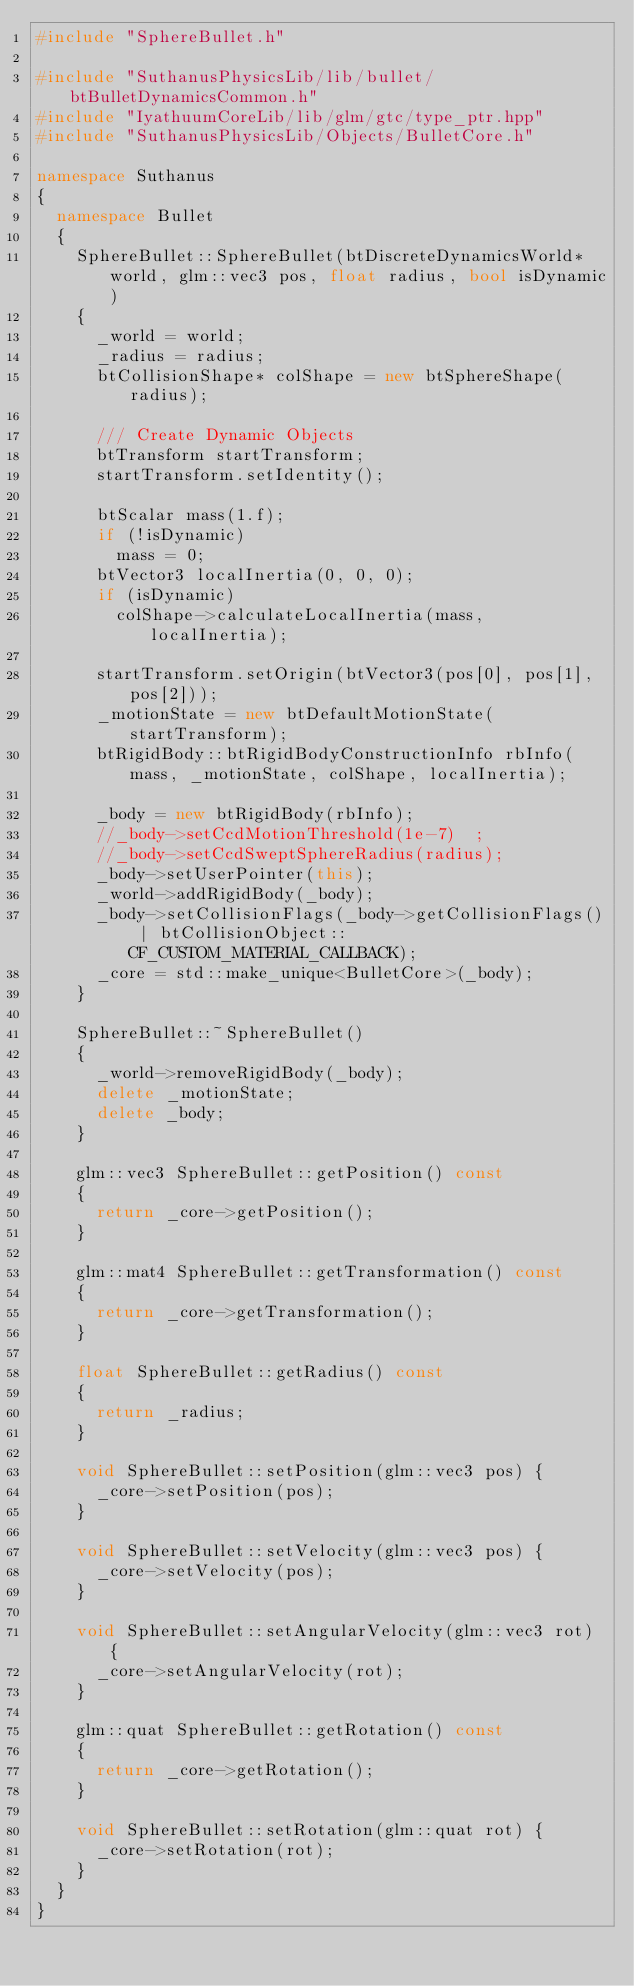<code> <loc_0><loc_0><loc_500><loc_500><_C++_>#include "SphereBullet.h"

#include "SuthanusPhysicsLib/lib/bullet/btBulletDynamicsCommon.h"
#include "IyathuumCoreLib/lib/glm/gtc/type_ptr.hpp"
#include "SuthanusPhysicsLib/Objects/BulletCore.h"

namespace Suthanus
{
  namespace Bullet
  {
    SphereBullet::SphereBullet(btDiscreteDynamicsWorld* world, glm::vec3 pos, float radius, bool isDynamic)
    {
      _world = world;
      _radius = radius;
      btCollisionShape* colShape = new btSphereShape(radius);

      /// Create Dynamic Objects
      btTransform startTransform;
      startTransform.setIdentity();

      btScalar mass(1.f);
      if (!isDynamic)
        mass = 0;
      btVector3 localInertia(0, 0, 0);
      if (isDynamic)
        colShape->calculateLocalInertia(mass, localInertia);

      startTransform.setOrigin(btVector3(pos[0], pos[1], pos[2]));
      _motionState = new btDefaultMotionState(startTransform);
      btRigidBody::btRigidBodyConstructionInfo rbInfo(mass, _motionState, colShape, localInertia);

      _body = new btRigidBody(rbInfo);
      //_body->setCcdMotionThreshold(1e-7)  ;
      //_body->setCcdSweptSphereRadius(radius);
      _body->setUserPointer(this);
      _world->addRigidBody(_body);
      _body->setCollisionFlags(_body->getCollisionFlags() | btCollisionObject::CF_CUSTOM_MATERIAL_CALLBACK);
      _core = std::make_unique<BulletCore>(_body);
    }

    SphereBullet::~SphereBullet()
    {
      _world->removeRigidBody(_body);
      delete _motionState;
      delete _body;
    }

    glm::vec3 SphereBullet::getPosition() const
    {
      return _core->getPosition();
    }

    glm::mat4 SphereBullet::getTransformation() const
    {
      return _core->getTransformation();
    }

    float SphereBullet::getRadius() const
    {
      return _radius;
    }

    void SphereBullet::setPosition(glm::vec3 pos) {
      _core->setPosition(pos);
    }

    void SphereBullet::setVelocity(glm::vec3 pos) {
      _core->setVelocity(pos);
    }

    void SphereBullet::setAngularVelocity(glm::vec3 rot) {
      _core->setAngularVelocity(rot);
    }

    glm::quat SphereBullet::getRotation() const
    {
      return _core->getRotation();
    }

    void SphereBullet::setRotation(glm::quat rot) {
      _core->setRotation(rot);
    }
  }
}</code> 